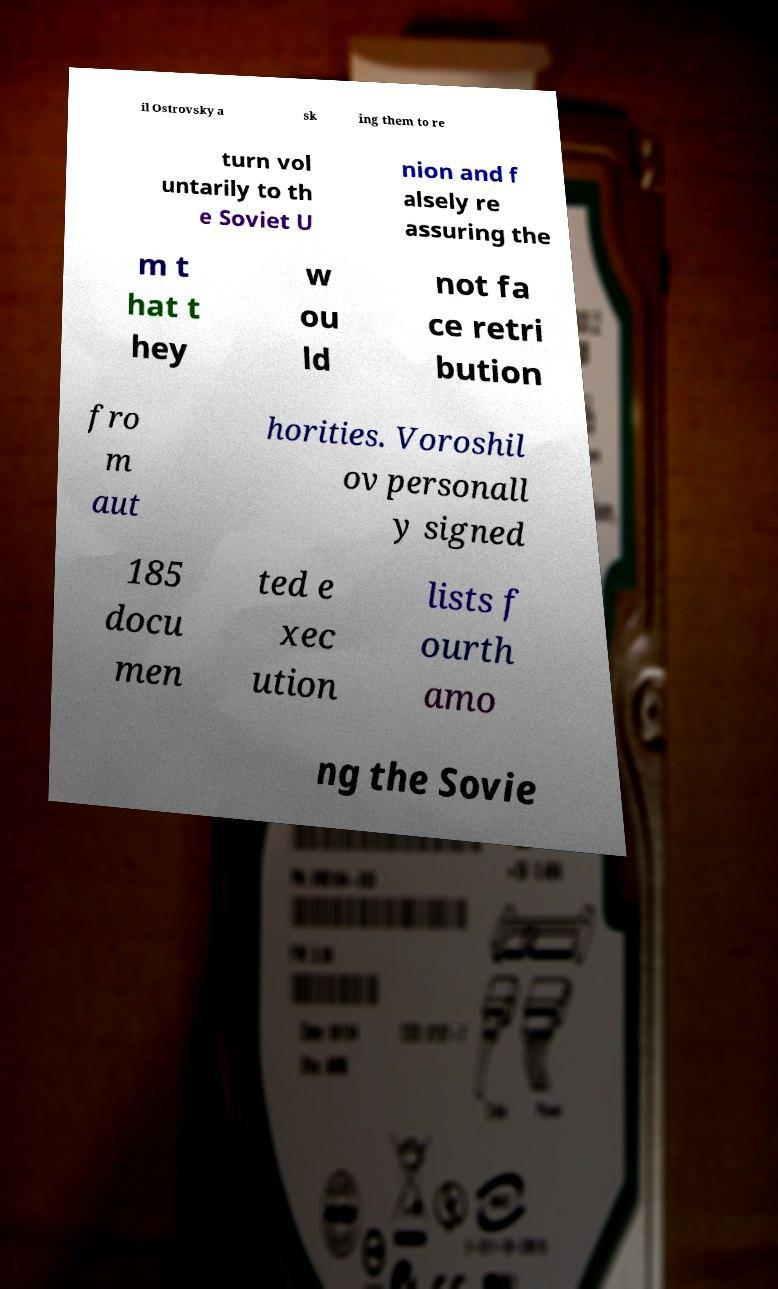Please identify and transcribe the text found in this image. il Ostrovsky a sk ing them to re turn vol untarily to th e Soviet U nion and f alsely re assuring the m t hat t hey w ou ld not fa ce retri bution fro m aut horities. Voroshil ov personall y signed 185 docu men ted e xec ution lists f ourth amo ng the Sovie 